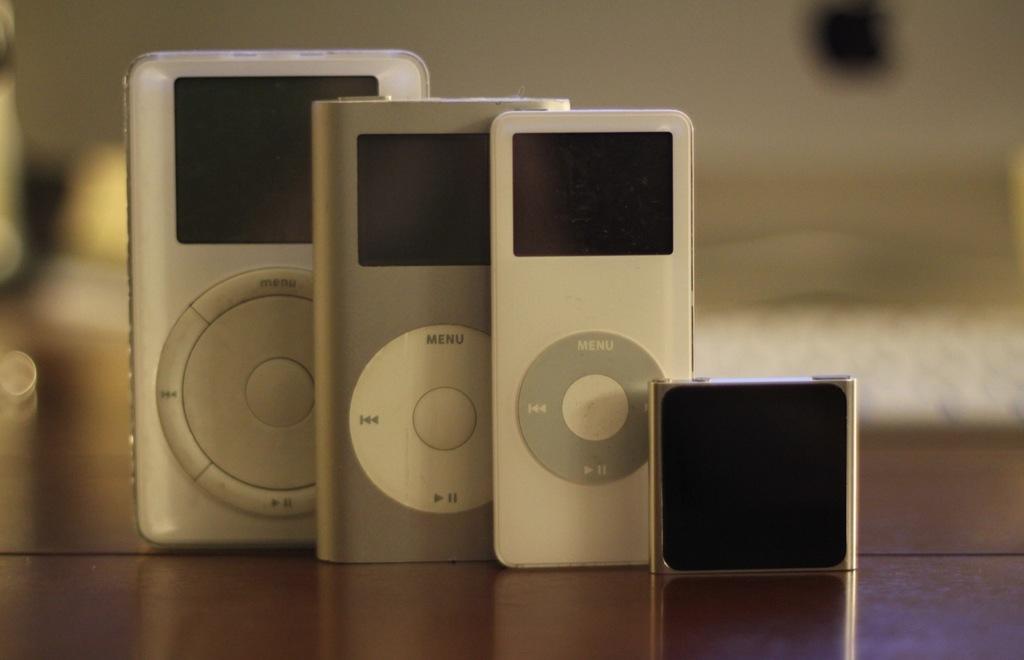How many devices?
Keep it short and to the point. Answering does not require reading text in the image. What is the top button for on the one on the left?
Offer a very short reply. Menu. 